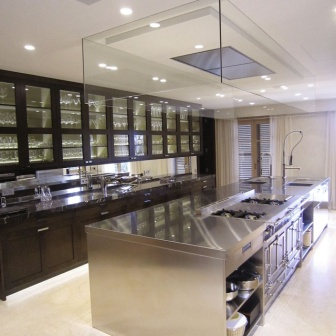What do you see happening in this image? The image showcases a modern, high-end kitchen filled with elegant features. At the center is a large kitchen island with a gleaming stainless steel countertop. This island includes a sink with a tall, sophisticated faucet and two stovetops on either side, ensuring ample space for cooking. Beneath the countertop, a shelf provides additional storage.

On both sides of the kitchen, dark wood cabinets with glass doors add a touch of sophistication, reflecting the room's soft lighting from a rectangular ceiling fixture. Inside each cabinet, small lights create a warm and inviting atmosphere. To the right, a large window adorned with white blinds allows natural light to flood the space, enhancing the room's brightness.

The floor features light-colored tiles that complement the kitchen's overall aesthetic. Despite the abundance of features, the room maintains a sense of order and symmetry, with the island serving as the focal point. Each element is carefully placed, showcasing both functionality and visual appeal. 